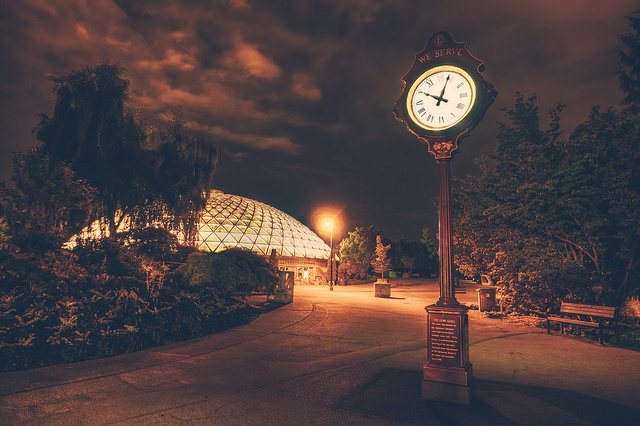Describe the objects in this image and their specific colors. I can see clock in black, ivory, khaki, and tan tones and bench in black, maroon, and brown tones in this image. 